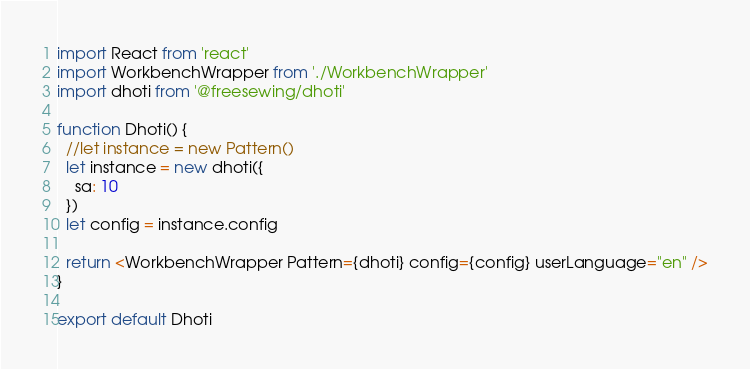<code> <loc_0><loc_0><loc_500><loc_500><_JavaScript_>import React from 'react'
import WorkbenchWrapper from './WorkbenchWrapper'
import dhoti from '@freesewing/dhoti'

function Dhoti() {
  //let instance = new Pattern()
  let instance = new dhoti({
    sa: 10
  })
  let config = instance.config

  return <WorkbenchWrapper Pattern={dhoti} config={config} userLanguage="en" />
}

export default Dhoti
</code> 